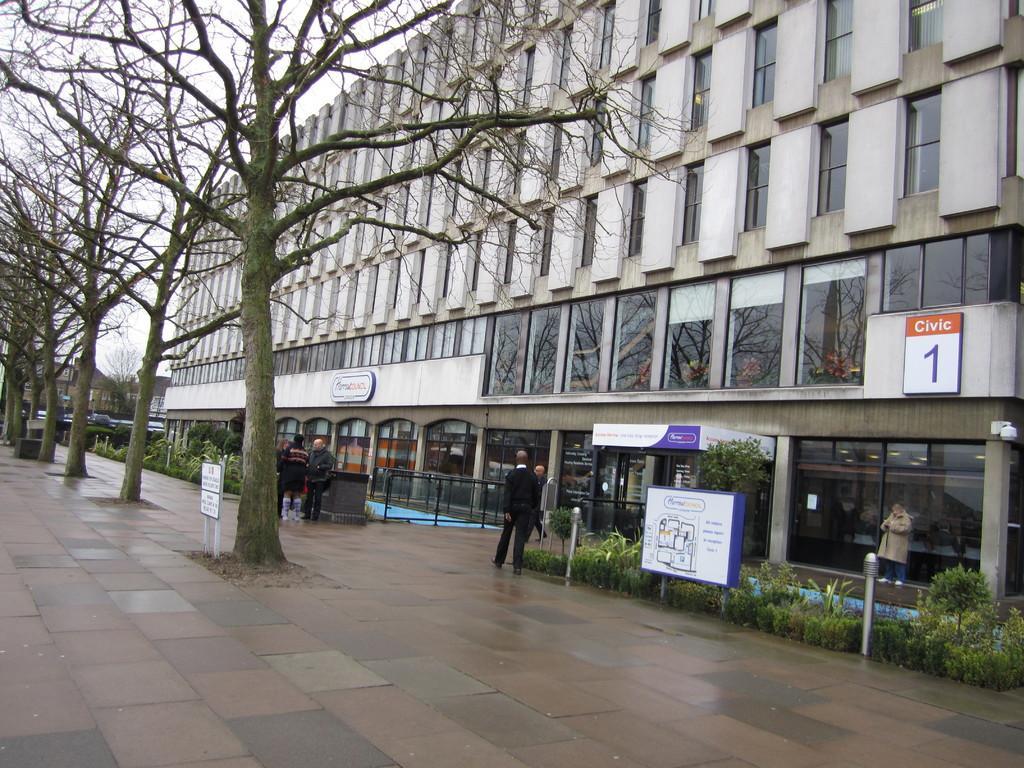Could you give a brief overview of what you see in this image? In the foreground of this image, there are trees and a board on the side path. On the right, there is a building, few boards, plants and bollards. We can also see people standing and walking. At the top, there is the sky. 